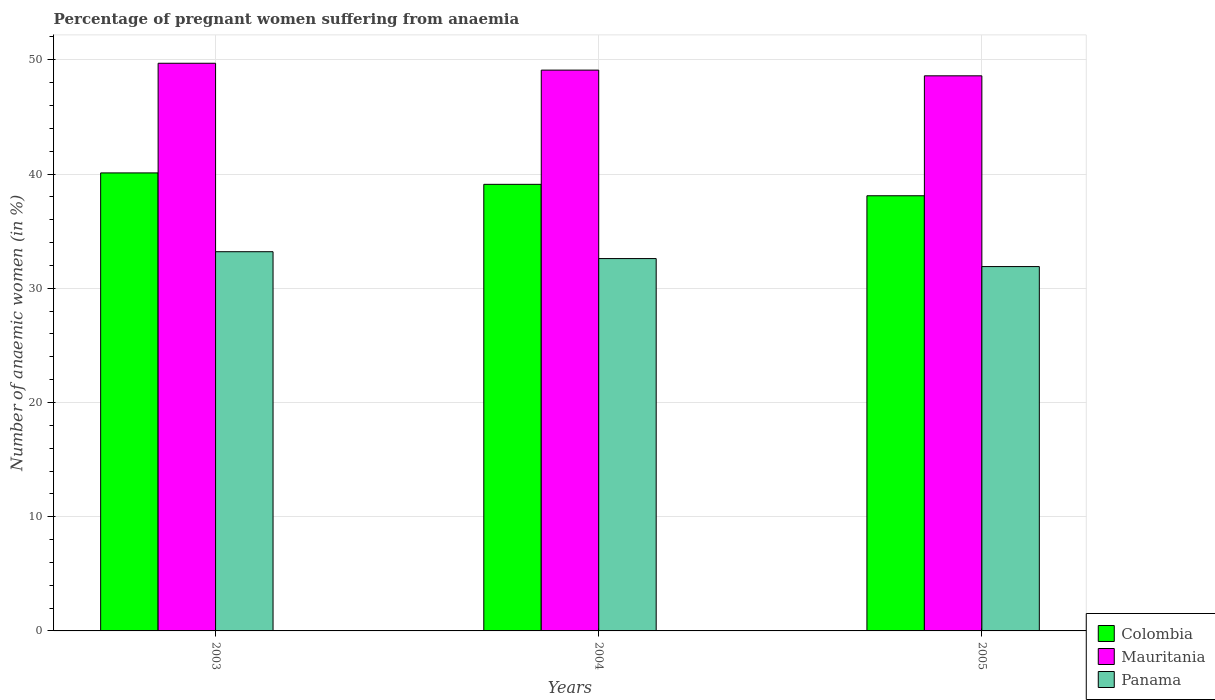How many different coloured bars are there?
Make the answer very short. 3. How many groups of bars are there?
Provide a succinct answer. 3. Are the number of bars per tick equal to the number of legend labels?
Your response must be concise. Yes. How many bars are there on the 2nd tick from the left?
Offer a very short reply. 3. How many bars are there on the 2nd tick from the right?
Your response must be concise. 3. In how many cases, is the number of bars for a given year not equal to the number of legend labels?
Offer a very short reply. 0. What is the number of anaemic women in Mauritania in 2003?
Offer a terse response. 49.7. Across all years, what is the maximum number of anaemic women in Colombia?
Your response must be concise. 40.1. Across all years, what is the minimum number of anaemic women in Mauritania?
Your answer should be very brief. 48.6. What is the total number of anaemic women in Mauritania in the graph?
Provide a succinct answer. 147.4. What is the difference between the number of anaemic women in Panama in 2003 and that in 2004?
Offer a very short reply. 0.6. What is the difference between the number of anaemic women in Mauritania in 2005 and the number of anaemic women in Colombia in 2003?
Offer a very short reply. 8.5. What is the average number of anaemic women in Mauritania per year?
Provide a succinct answer. 49.13. In the year 2004, what is the difference between the number of anaemic women in Mauritania and number of anaemic women in Colombia?
Offer a terse response. 10. In how many years, is the number of anaemic women in Colombia greater than 18 %?
Keep it short and to the point. 3. What is the ratio of the number of anaemic women in Colombia in 2003 to that in 2004?
Your response must be concise. 1.03. Is the number of anaemic women in Panama in 2003 less than that in 2005?
Your answer should be very brief. No. Is the difference between the number of anaemic women in Mauritania in 2004 and 2005 greater than the difference between the number of anaemic women in Colombia in 2004 and 2005?
Provide a succinct answer. No. What is the difference between the highest and the second highest number of anaemic women in Mauritania?
Give a very brief answer. 0.6. What is the difference between the highest and the lowest number of anaemic women in Panama?
Offer a terse response. 1.3. Is the sum of the number of anaemic women in Mauritania in 2004 and 2005 greater than the maximum number of anaemic women in Panama across all years?
Your answer should be very brief. Yes. What does the 1st bar from the left in 2003 represents?
Provide a succinct answer. Colombia. What does the 2nd bar from the right in 2004 represents?
Your response must be concise. Mauritania. How many bars are there?
Provide a succinct answer. 9. What is the difference between two consecutive major ticks on the Y-axis?
Your answer should be very brief. 10. Are the values on the major ticks of Y-axis written in scientific E-notation?
Make the answer very short. No. Does the graph contain any zero values?
Provide a succinct answer. No. Does the graph contain grids?
Provide a short and direct response. Yes. Where does the legend appear in the graph?
Offer a terse response. Bottom right. How many legend labels are there?
Offer a terse response. 3. What is the title of the graph?
Your response must be concise. Percentage of pregnant women suffering from anaemia. What is the label or title of the X-axis?
Offer a terse response. Years. What is the label or title of the Y-axis?
Give a very brief answer. Number of anaemic women (in %). What is the Number of anaemic women (in %) in Colombia in 2003?
Offer a terse response. 40.1. What is the Number of anaemic women (in %) of Mauritania in 2003?
Offer a very short reply. 49.7. What is the Number of anaemic women (in %) in Panama in 2003?
Provide a short and direct response. 33.2. What is the Number of anaemic women (in %) in Colombia in 2004?
Keep it short and to the point. 39.1. What is the Number of anaemic women (in %) in Mauritania in 2004?
Offer a very short reply. 49.1. What is the Number of anaemic women (in %) of Panama in 2004?
Your answer should be compact. 32.6. What is the Number of anaemic women (in %) of Colombia in 2005?
Offer a terse response. 38.1. What is the Number of anaemic women (in %) in Mauritania in 2005?
Keep it short and to the point. 48.6. What is the Number of anaemic women (in %) of Panama in 2005?
Keep it short and to the point. 31.9. Across all years, what is the maximum Number of anaemic women (in %) of Colombia?
Provide a short and direct response. 40.1. Across all years, what is the maximum Number of anaemic women (in %) of Mauritania?
Your response must be concise. 49.7. Across all years, what is the maximum Number of anaemic women (in %) of Panama?
Make the answer very short. 33.2. Across all years, what is the minimum Number of anaemic women (in %) of Colombia?
Make the answer very short. 38.1. Across all years, what is the minimum Number of anaemic women (in %) of Mauritania?
Provide a succinct answer. 48.6. Across all years, what is the minimum Number of anaemic women (in %) of Panama?
Your response must be concise. 31.9. What is the total Number of anaemic women (in %) in Colombia in the graph?
Provide a succinct answer. 117.3. What is the total Number of anaemic women (in %) in Mauritania in the graph?
Your answer should be very brief. 147.4. What is the total Number of anaemic women (in %) of Panama in the graph?
Offer a terse response. 97.7. What is the difference between the Number of anaemic women (in %) of Mauritania in 2003 and that in 2004?
Ensure brevity in your answer.  0.6. What is the difference between the Number of anaemic women (in %) of Panama in 2003 and that in 2005?
Your answer should be compact. 1.3. What is the difference between the Number of anaemic women (in %) of Colombia in 2004 and that in 2005?
Your response must be concise. 1. What is the difference between the Number of anaemic women (in %) in Colombia in 2003 and the Number of anaemic women (in %) in Panama in 2004?
Your answer should be compact. 7.5. What is the difference between the Number of anaemic women (in %) of Mauritania in 2003 and the Number of anaemic women (in %) of Panama in 2004?
Give a very brief answer. 17.1. What is the difference between the Number of anaemic women (in %) in Mauritania in 2003 and the Number of anaemic women (in %) in Panama in 2005?
Offer a very short reply. 17.8. What is the difference between the Number of anaemic women (in %) of Colombia in 2004 and the Number of anaemic women (in %) of Panama in 2005?
Your response must be concise. 7.2. What is the average Number of anaemic women (in %) in Colombia per year?
Offer a terse response. 39.1. What is the average Number of anaemic women (in %) in Mauritania per year?
Make the answer very short. 49.13. What is the average Number of anaemic women (in %) of Panama per year?
Provide a short and direct response. 32.57. In the year 2003, what is the difference between the Number of anaemic women (in %) of Mauritania and Number of anaemic women (in %) of Panama?
Offer a terse response. 16.5. In the year 2004, what is the difference between the Number of anaemic women (in %) in Mauritania and Number of anaemic women (in %) in Panama?
Provide a short and direct response. 16.5. In the year 2005, what is the difference between the Number of anaemic women (in %) in Colombia and Number of anaemic women (in %) in Mauritania?
Give a very brief answer. -10.5. In the year 2005, what is the difference between the Number of anaemic women (in %) of Colombia and Number of anaemic women (in %) of Panama?
Provide a short and direct response. 6.2. In the year 2005, what is the difference between the Number of anaemic women (in %) of Mauritania and Number of anaemic women (in %) of Panama?
Give a very brief answer. 16.7. What is the ratio of the Number of anaemic women (in %) of Colombia in 2003 to that in 2004?
Give a very brief answer. 1.03. What is the ratio of the Number of anaemic women (in %) of Mauritania in 2003 to that in 2004?
Your response must be concise. 1.01. What is the ratio of the Number of anaemic women (in %) of Panama in 2003 to that in 2004?
Offer a terse response. 1.02. What is the ratio of the Number of anaemic women (in %) of Colombia in 2003 to that in 2005?
Provide a succinct answer. 1.05. What is the ratio of the Number of anaemic women (in %) in Mauritania in 2003 to that in 2005?
Offer a terse response. 1.02. What is the ratio of the Number of anaemic women (in %) in Panama in 2003 to that in 2005?
Your response must be concise. 1.04. What is the ratio of the Number of anaemic women (in %) in Colombia in 2004 to that in 2005?
Provide a succinct answer. 1.03. What is the ratio of the Number of anaemic women (in %) of Mauritania in 2004 to that in 2005?
Your answer should be very brief. 1.01. What is the ratio of the Number of anaemic women (in %) of Panama in 2004 to that in 2005?
Give a very brief answer. 1.02. What is the difference between the highest and the second highest Number of anaemic women (in %) of Mauritania?
Give a very brief answer. 0.6. What is the difference between the highest and the lowest Number of anaemic women (in %) in Colombia?
Provide a succinct answer. 2. What is the difference between the highest and the lowest Number of anaemic women (in %) in Mauritania?
Keep it short and to the point. 1.1. What is the difference between the highest and the lowest Number of anaemic women (in %) in Panama?
Keep it short and to the point. 1.3. 